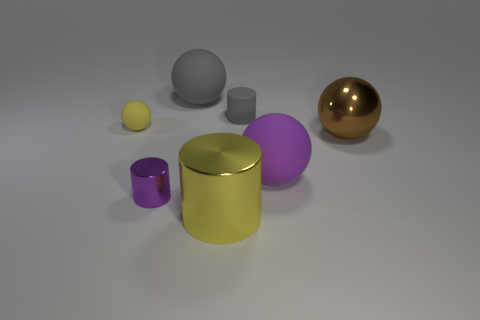Are there fewer big matte things that are on the left side of the big yellow cylinder than small blue balls?
Offer a terse response. No. Is the tiny yellow sphere made of the same material as the gray cylinder?
Provide a succinct answer. Yes. How many objects are yellow balls or small red metal cylinders?
Provide a short and direct response. 1. What number of other tiny cylinders are the same material as the purple cylinder?
Offer a very short reply. 0. What size is the other metallic thing that is the same shape as the yellow metal object?
Keep it short and to the point. Small. There is a small purple cylinder; are there any small yellow objects right of it?
Offer a very short reply. No. What is the small yellow thing made of?
Give a very brief answer. Rubber. There is a small matte object that is behind the small yellow object; is it the same color as the big cylinder?
Offer a very short reply. No. There is another metallic object that is the same shape as the purple shiny object; what is its color?
Offer a terse response. Yellow. What is the material of the cylinder in front of the tiny purple metal object?
Keep it short and to the point. Metal. 